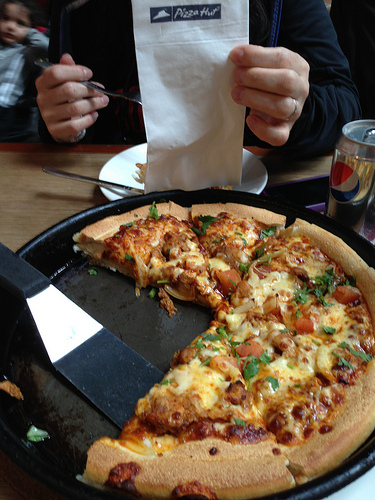Describe the type of pizza in the image. The pizza shown in the image is likely a veggie pizza with various toppings such as tomatoes, onions, and possibly green peppers, baked with a generous amount of cheese. The crust appears thick and golden brown. What drinks are present in the image? The image shows a can of Pepsi on the right side of the table next to the pizza. Where is the Pizza Hut logo located? The Pizza Hut logo is visible on a napkin that the person is holding up in the image. Imagine the pizza could talk, what might it say? 'Hey there, dig in! I'm fresh out of the oven, loaded with delicious toppings and melted cheese. Don't worry about getting your hands messy, I'm worth it!' 